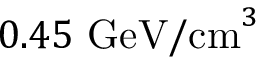<formula> <loc_0><loc_0><loc_500><loc_500>0 . 4 5 \ G e V / c m ^ { 3 }</formula> 